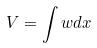<formula> <loc_0><loc_0><loc_500><loc_500>V = \int w d x</formula> 